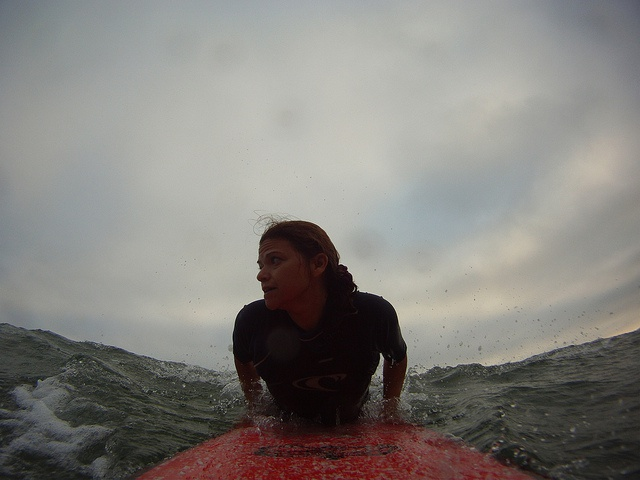Describe the objects in this image and their specific colors. I can see people in gray, black, darkgray, and maroon tones and surfboard in gray, maroon, black, and brown tones in this image. 